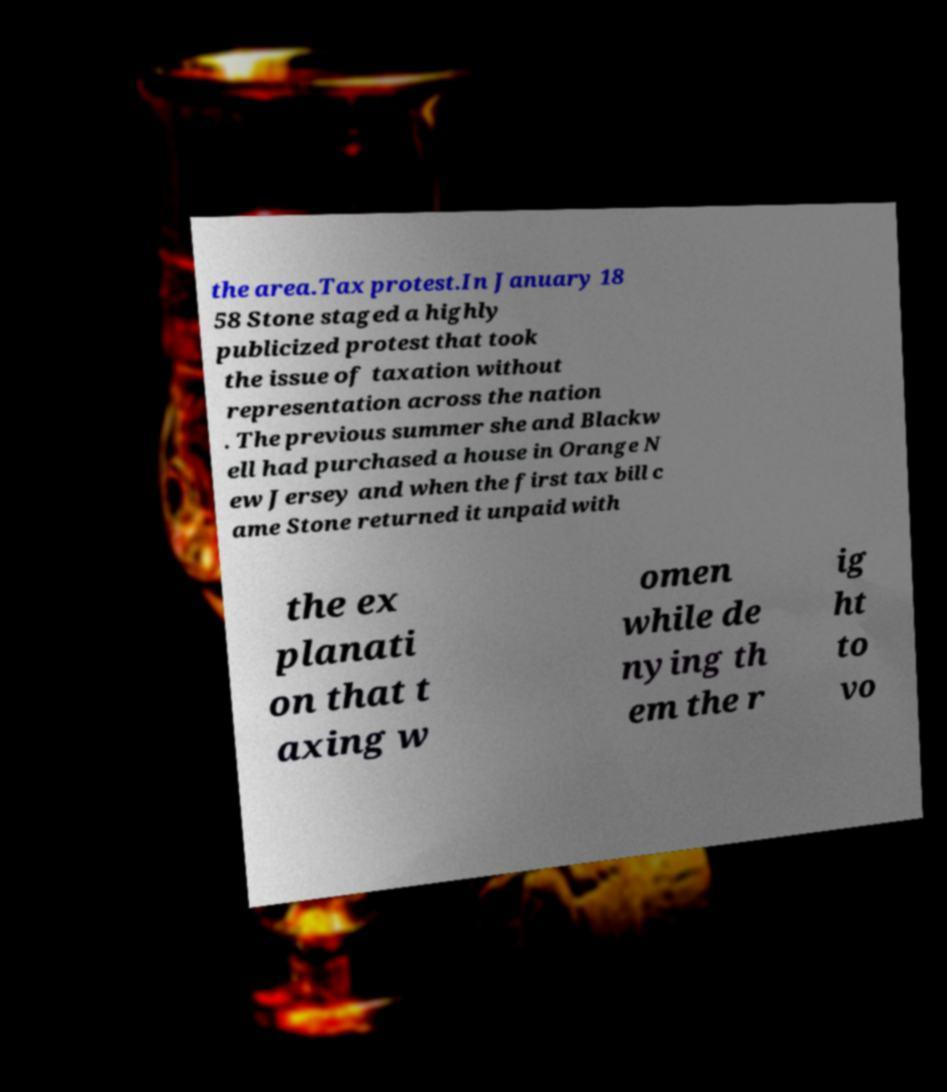Can you read and provide the text displayed in the image?This photo seems to have some interesting text. Can you extract and type it out for me? the area.Tax protest.In January 18 58 Stone staged a highly publicized protest that took the issue of taxation without representation across the nation . The previous summer she and Blackw ell had purchased a house in Orange N ew Jersey and when the first tax bill c ame Stone returned it unpaid with the ex planati on that t axing w omen while de nying th em the r ig ht to vo 